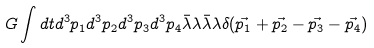Convert formula to latex. <formula><loc_0><loc_0><loc_500><loc_500>G \int d t d ^ { 3 } p _ { 1 } d ^ { 3 } p _ { 2 } d ^ { 3 } p _ { 3 } d ^ { 3 } p _ { 4 } \bar { \lambda } \lambda \bar { \lambda } \lambda \delta ( \vec { p _ { 1 } } + \vec { p _ { 2 } } - \vec { p _ { 3 } } - \vec { p _ { 4 } } )</formula> 